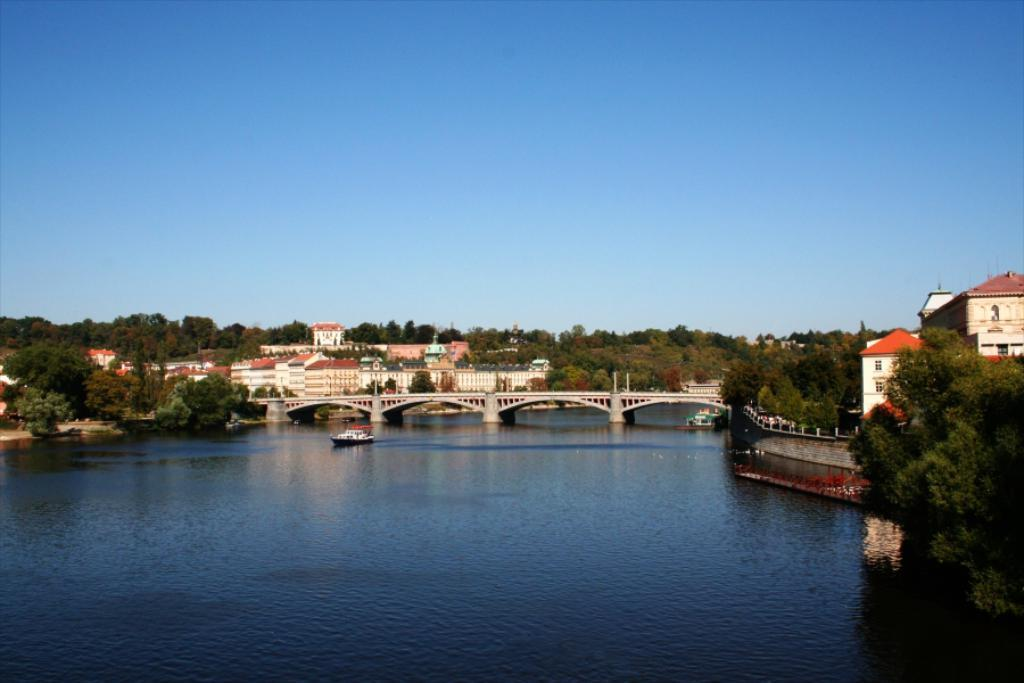What type of natural elements can be seen in the image? There are trees in the image. What type of man-made structures are visible in the image? There are buildings in the image. What connects the two sides of the water in the image? There is a bridge in the middle of the image. What type of vehicle is floating on the water in the image? There is a boat floating on the water in the image. What is visible at the top of the image? The sky is visible at the top of the image. What is the condition of the frame around the image? There is no frame around the image; the question is not relevant to the content of the image. 